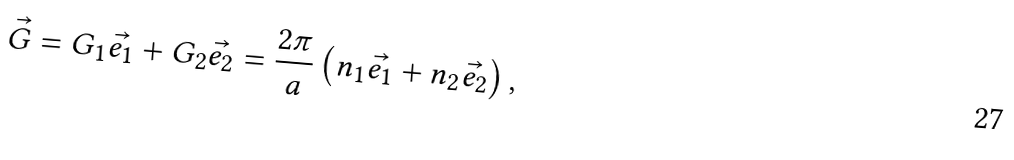Convert formula to latex. <formula><loc_0><loc_0><loc_500><loc_500>\vec { G } = G _ { 1 } \vec { e _ { 1 } } + G _ { 2 } \vec { e _ { 2 } } = \frac { 2 \pi } { a } \left ( n _ { 1 } \vec { e _ { 1 } } + n _ { 2 } \vec { e _ { 2 } } \right ) ,</formula> 